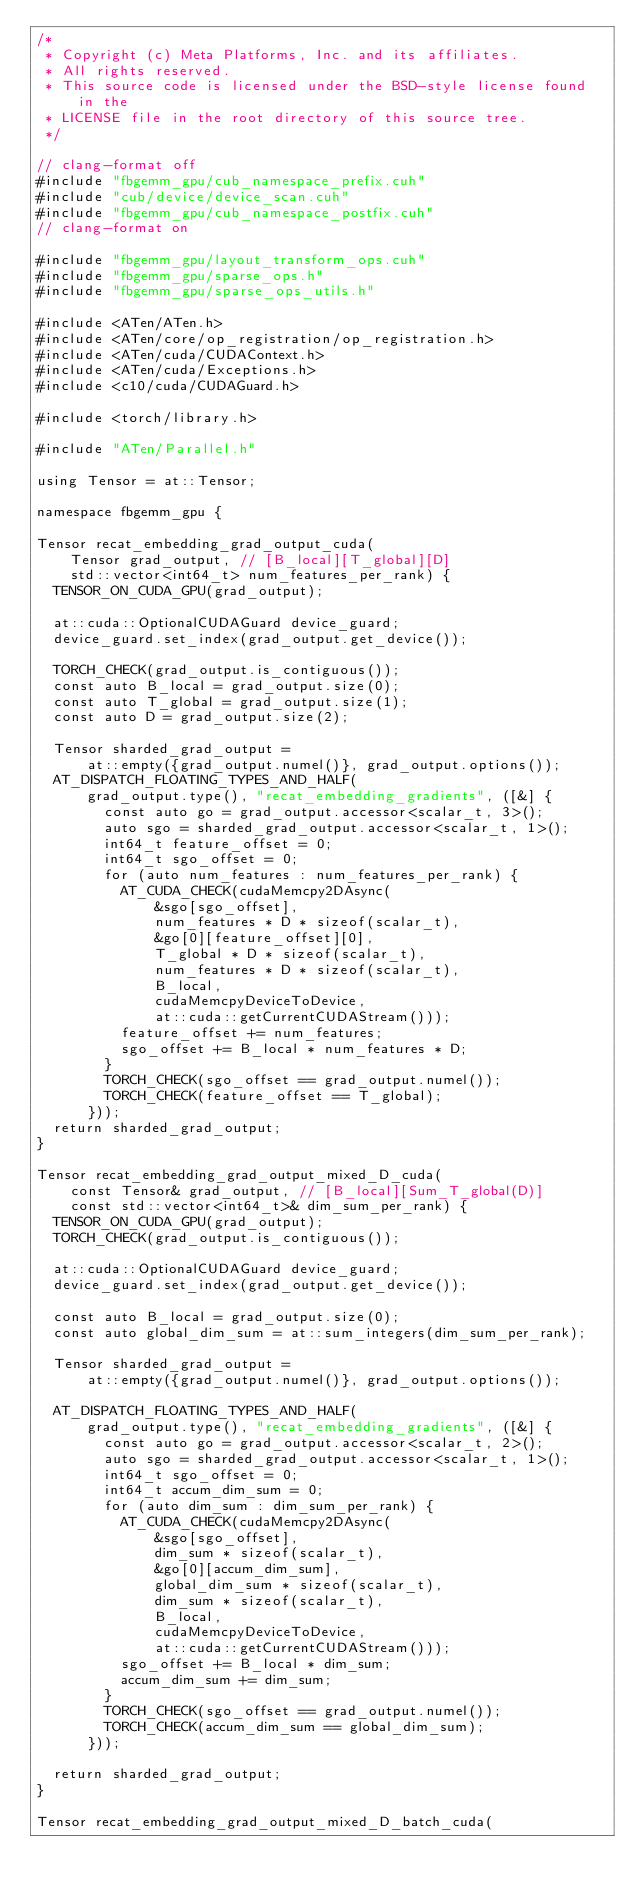<code> <loc_0><loc_0><loc_500><loc_500><_Cuda_>/*
 * Copyright (c) Meta Platforms, Inc. and its affiliates.
 * All rights reserved.
 * This source code is licensed under the BSD-style license found in the
 * LICENSE file in the root directory of this source tree.
 */

// clang-format off
#include "fbgemm_gpu/cub_namespace_prefix.cuh"
#include "cub/device/device_scan.cuh"
#include "fbgemm_gpu/cub_namespace_postfix.cuh"
// clang-format on

#include "fbgemm_gpu/layout_transform_ops.cuh"
#include "fbgemm_gpu/sparse_ops.h"
#include "fbgemm_gpu/sparse_ops_utils.h"

#include <ATen/ATen.h>
#include <ATen/core/op_registration/op_registration.h>
#include <ATen/cuda/CUDAContext.h>
#include <ATen/cuda/Exceptions.h>
#include <c10/cuda/CUDAGuard.h>

#include <torch/library.h>

#include "ATen/Parallel.h"

using Tensor = at::Tensor;

namespace fbgemm_gpu {

Tensor recat_embedding_grad_output_cuda(
    Tensor grad_output, // [B_local][T_global][D]
    std::vector<int64_t> num_features_per_rank) {
  TENSOR_ON_CUDA_GPU(grad_output);

  at::cuda::OptionalCUDAGuard device_guard;
  device_guard.set_index(grad_output.get_device());

  TORCH_CHECK(grad_output.is_contiguous());
  const auto B_local = grad_output.size(0);
  const auto T_global = grad_output.size(1);
  const auto D = grad_output.size(2);

  Tensor sharded_grad_output =
      at::empty({grad_output.numel()}, grad_output.options());
  AT_DISPATCH_FLOATING_TYPES_AND_HALF(
      grad_output.type(), "recat_embedding_gradients", ([&] {
        const auto go = grad_output.accessor<scalar_t, 3>();
        auto sgo = sharded_grad_output.accessor<scalar_t, 1>();
        int64_t feature_offset = 0;
        int64_t sgo_offset = 0;
        for (auto num_features : num_features_per_rank) {
          AT_CUDA_CHECK(cudaMemcpy2DAsync(
              &sgo[sgo_offset],
              num_features * D * sizeof(scalar_t),
              &go[0][feature_offset][0],
              T_global * D * sizeof(scalar_t),
              num_features * D * sizeof(scalar_t),
              B_local,
              cudaMemcpyDeviceToDevice,
              at::cuda::getCurrentCUDAStream()));
          feature_offset += num_features;
          sgo_offset += B_local * num_features * D;
        }
        TORCH_CHECK(sgo_offset == grad_output.numel());
        TORCH_CHECK(feature_offset == T_global);
      }));
  return sharded_grad_output;
}

Tensor recat_embedding_grad_output_mixed_D_cuda(
    const Tensor& grad_output, // [B_local][Sum_T_global(D)]
    const std::vector<int64_t>& dim_sum_per_rank) {
  TENSOR_ON_CUDA_GPU(grad_output);
  TORCH_CHECK(grad_output.is_contiguous());

  at::cuda::OptionalCUDAGuard device_guard;
  device_guard.set_index(grad_output.get_device());

  const auto B_local = grad_output.size(0);
  const auto global_dim_sum = at::sum_integers(dim_sum_per_rank);

  Tensor sharded_grad_output =
      at::empty({grad_output.numel()}, grad_output.options());

  AT_DISPATCH_FLOATING_TYPES_AND_HALF(
      grad_output.type(), "recat_embedding_gradients", ([&] {
        const auto go = grad_output.accessor<scalar_t, 2>();
        auto sgo = sharded_grad_output.accessor<scalar_t, 1>();
        int64_t sgo_offset = 0;
        int64_t accum_dim_sum = 0;
        for (auto dim_sum : dim_sum_per_rank) {
          AT_CUDA_CHECK(cudaMemcpy2DAsync(
              &sgo[sgo_offset],
              dim_sum * sizeof(scalar_t),
              &go[0][accum_dim_sum],
              global_dim_sum * sizeof(scalar_t),
              dim_sum * sizeof(scalar_t),
              B_local,
              cudaMemcpyDeviceToDevice,
              at::cuda::getCurrentCUDAStream()));
          sgo_offset += B_local * dim_sum;
          accum_dim_sum += dim_sum;
        }
        TORCH_CHECK(sgo_offset == grad_output.numel());
        TORCH_CHECK(accum_dim_sum == global_dim_sum);
      }));

  return sharded_grad_output;
}

Tensor recat_embedding_grad_output_mixed_D_batch_cuda(</code> 